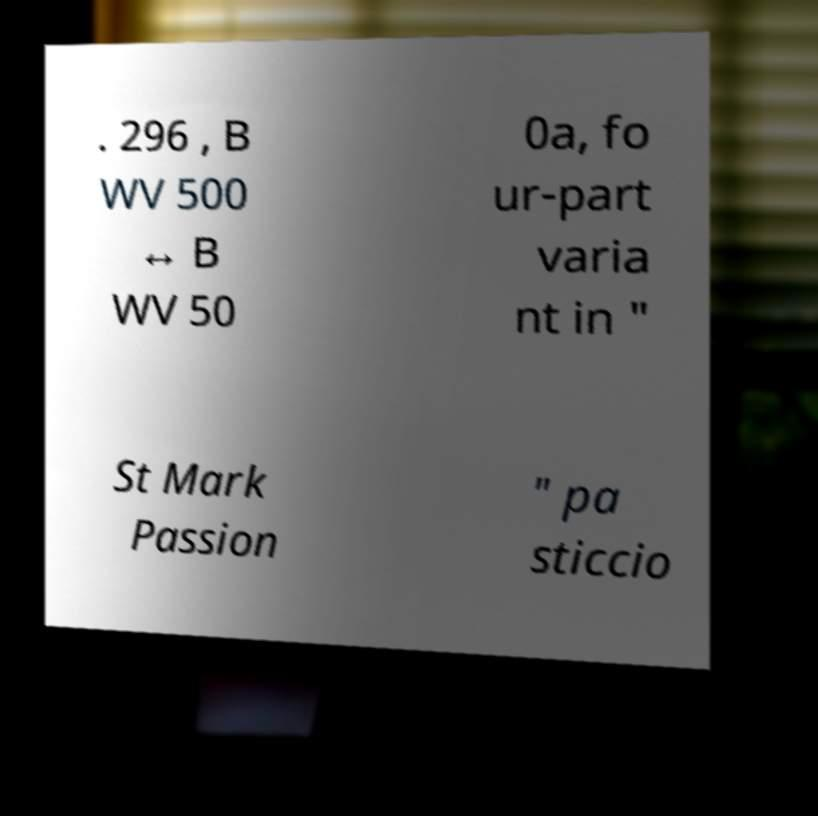Can you accurately transcribe the text from the provided image for me? . 296 , B WV 500 ↔ B WV 50 0a, fo ur-part varia nt in " St Mark Passion " pa sticcio 